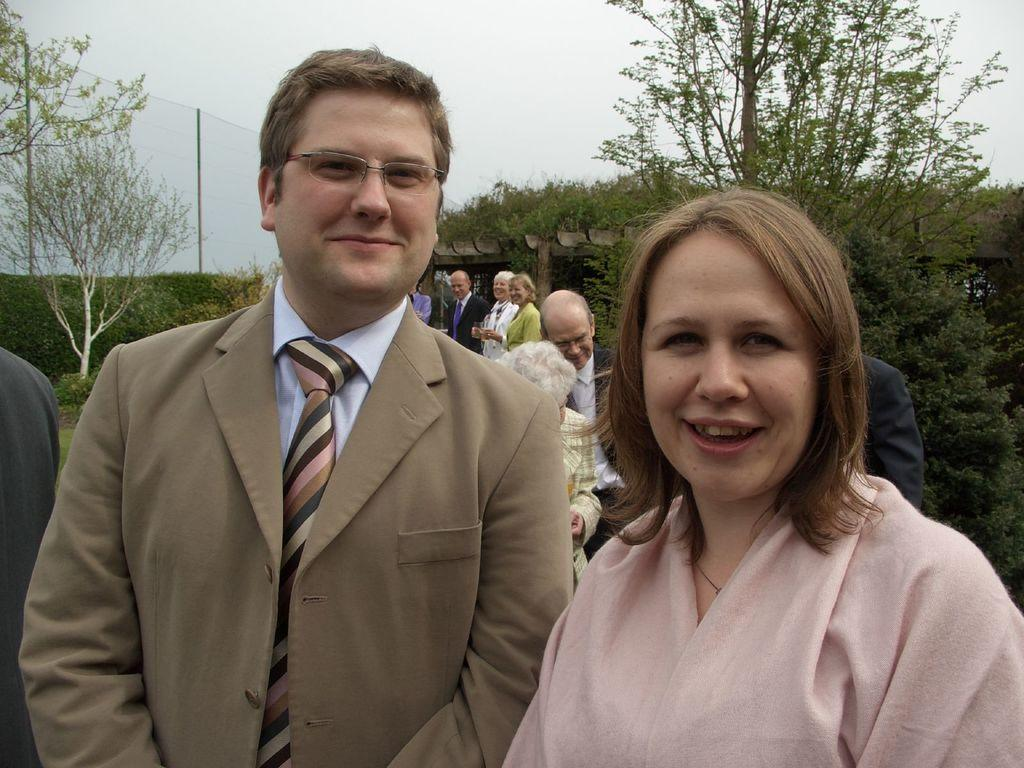How many people are in the image? There is a group of people in the image, but the exact number cannot be determined from the provided facts. What is located behind the people in the image? There are trees, a hedge, and a fence behind the people in the image. What can be seen in the background of the image? There appears to be an arch in the background. What is visible at the top of the image? The sky is visible at the top of the image. How many pizzas are being served to the people in the image? There is no mention of pizzas in the image, so it is not possible to answer this question. What type of pot is visible in the image? There is no pot present in the image. 